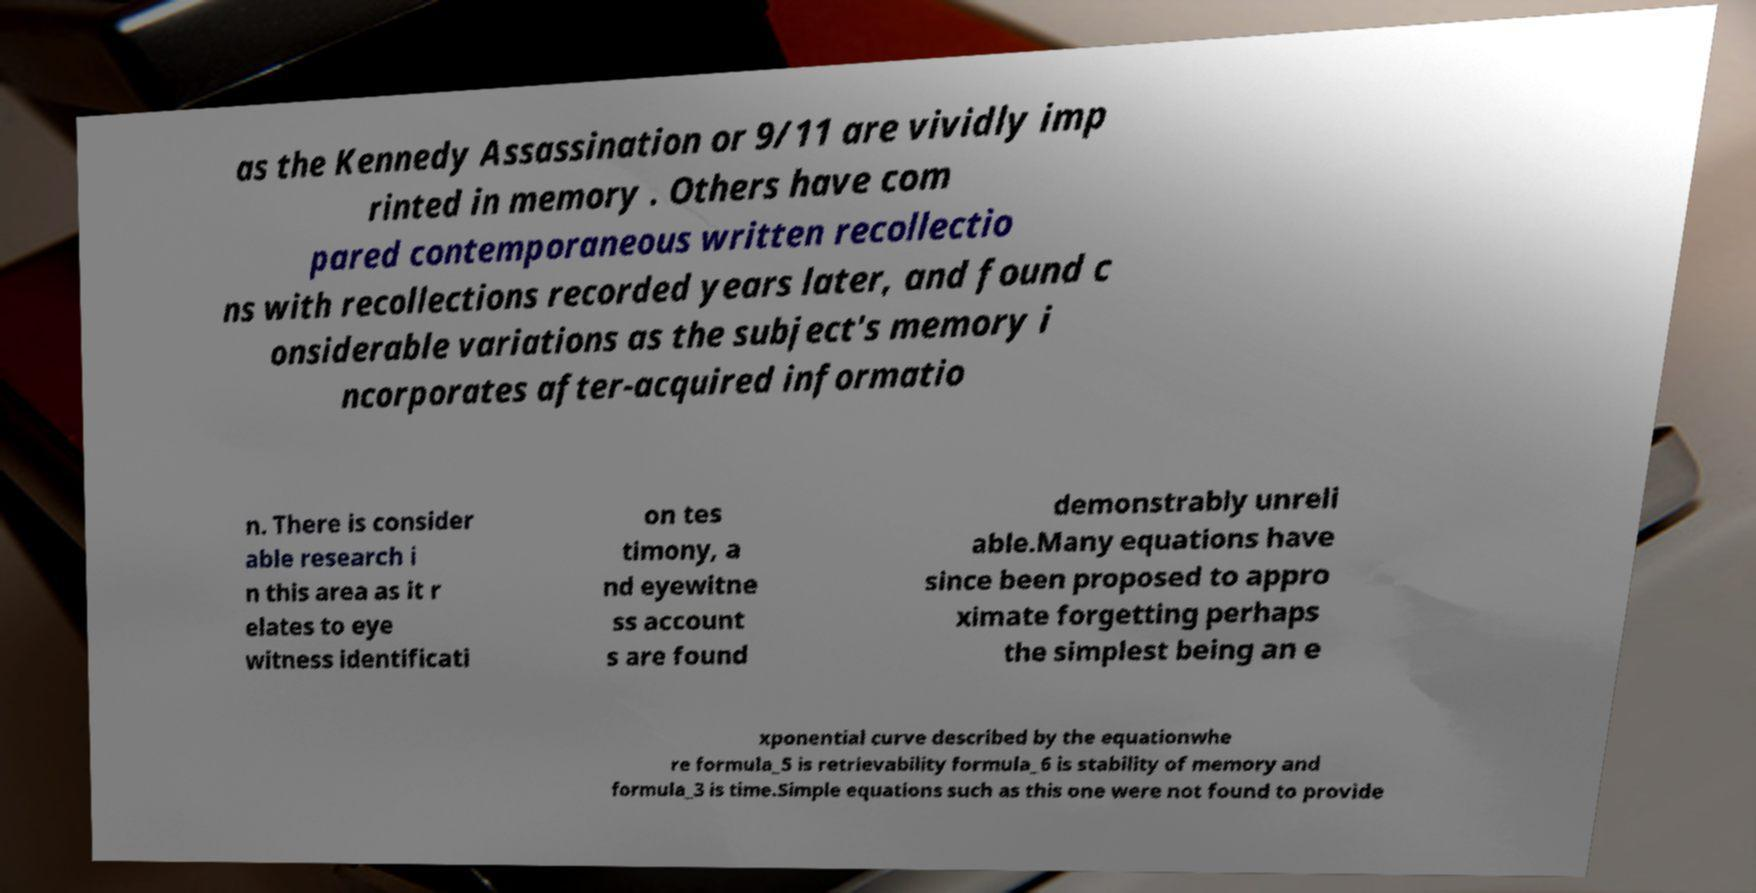What messages or text are displayed in this image? I need them in a readable, typed format. as the Kennedy Assassination or 9/11 are vividly imp rinted in memory . Others have com pared contemporaneous written recollectio ns with recollections recorded years later, and found c onsiderable variations as the subject's memory i ncorporates after-acquired informatio n. There is consider able research i n this area as it r elates to eye witness identificati on tes timony, a nd eyewitne ss account s are found demonstrably unreli able.Many equations have since been proposed to appro ximate forgetting perhaps the simplest being an e xponential curve described by the equationwhe re formula_5 is retrievability formula_6 is stability of memory and formula_3 is time.Simple equations such as this one were not found to provide 